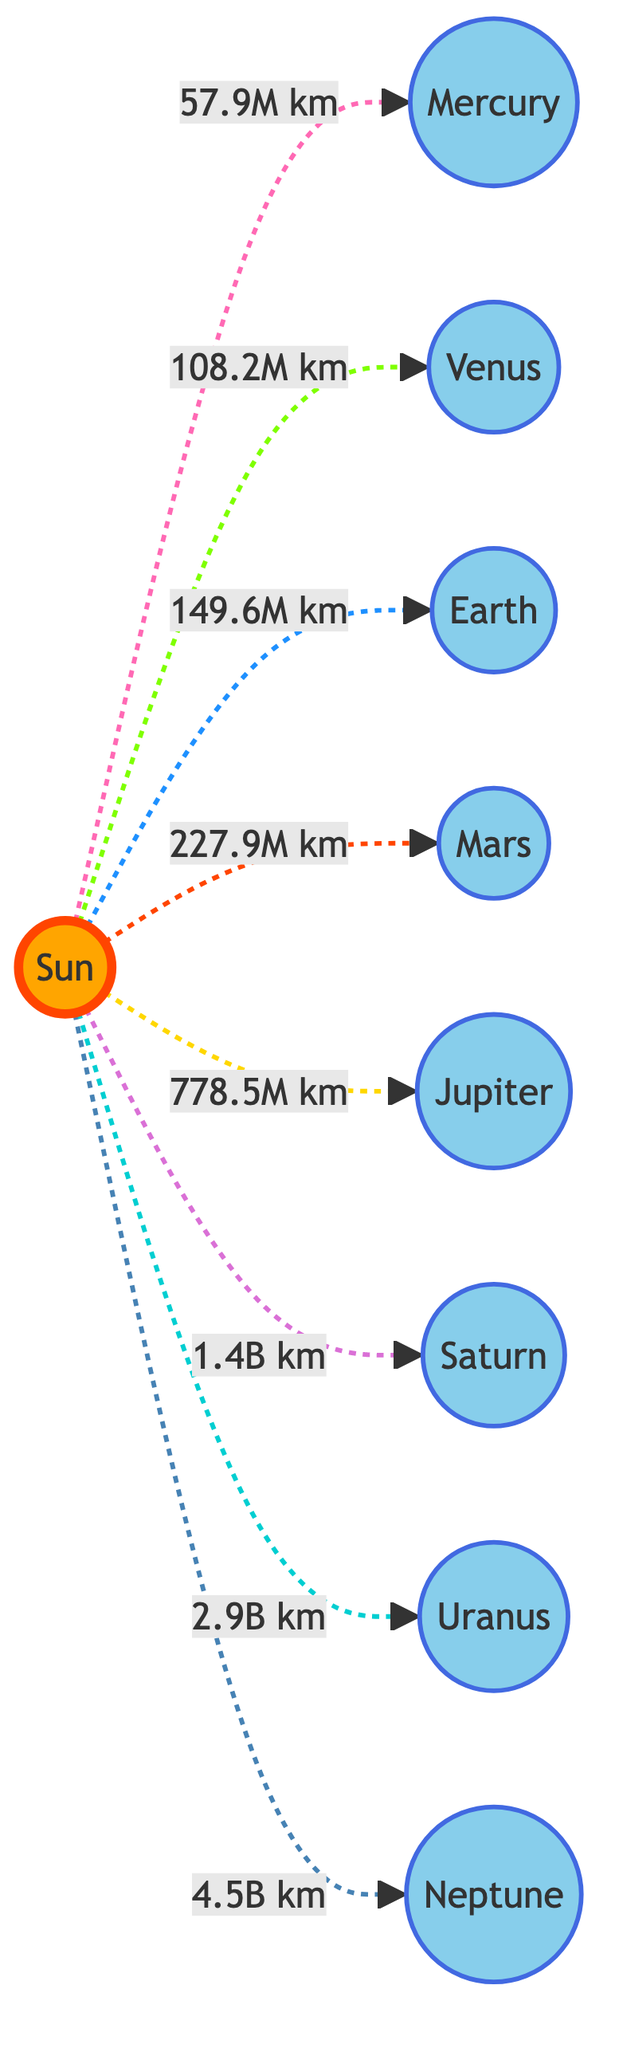What is the distance from the Sun to Jupiter? According to the diagram, the distance from the Sun to Jupiter is labeled as 778.5M km.
Answer: 778.5M km Which planet is furthest from the Sun? Neptune is indicated as the furthest planet from the Sun in the diagram, with a distance of 4.5B km.
Answer: Neptune How many planets are shown in the diagram? The diagram displays a total of 8 planets: Mercury, Venus, Earth, Mars, Jupiter, Saturn, Uranus, and Neptune.
Answer: 8 Which planet has the shortest distance from the Sun? By comparing the distances, Mercury is the closest planet to the Sun, listed with a distance of 57.9M km.
Answer: Mercury What color represents the Sun in the diagram? The diagram shows the Sun in an orange shade, indicated by the specified fill color.
Answer: Orange What is the distance from the Sun to Saturn? The diagram lists the distance to Saturn as 1.4B km from the Sun.
Answer: 1.4B km Which two planets have a similar distance from the Sun? Venus and Earth both have distances of 108.2M km and 149.6M km respectively, with Earth being 41.4M km farther than Venus, indicating no similar distance but closest proximity.
Answer: None Which planet is closest to Mars? The closest planet to Mars, based on the distances given, is Earth, which has a distance of 149.6M km from the Sun and is positioned between the Sun and Mars in distance.
Answer: Earth What is the connection type between the Sun and the planets? The connection between the Sun and the planets is indicated with dashed lines, suggesting a non-solid or indirect relationship.
Answer: Dashed lines 